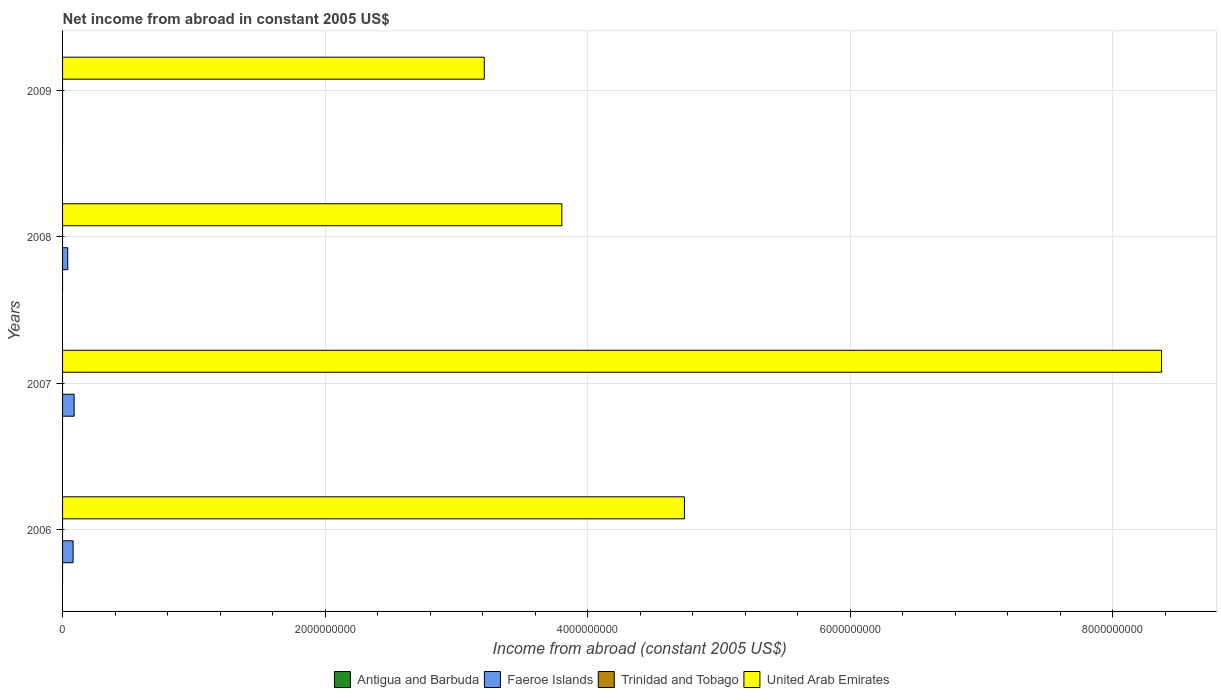How many different coloured bars are there?
Your answer should be very brief. 2. Are the number of bars per tick equal to the number of legend labels?
Provide a succinct answer. No. Are the number of bars on each tick of the Y-axis equal?
Provide a succinct answer. No. How many bars are there on the 1st tick from the bottom?
Your response must be concise. 2. What is the label of the 1st group of bars from the top?
Make the answer very short. 2009. What is the net income from abroad in United Arab Emirates in 2008?
Provide a succinct answer. 3.80e+09. Across all years, what is the maximum net income from abroad in United Arab Emirates?
Your answer should be compact. 8.37e+09. Across all years, what is the minimum net income from abroad in United Arab Emirates?
Keep it short and to the point. 3.21e+09. What is the total net income from abroad in Antigua and Barbuda in the graph?
Your answer should be very brief. 0. What is the difference between the net income from abroad in United Arab Emirates in 2006 and that in 2009?
Make the answer very short. 1.52e+09. What is the difference between the net income from abroad in United Arab Emirates in 2006 and the net income from abroad in Faeroe Islands in 2008?
Your answer should be very brief. 4.70e+09. What is the average net income from abroad in Antigua and Barbuda per year?
Your answer should be compact. 0. In how many years, is the net income from abroad in United Arab Emirates greater than 4800000000 US$?
Ensure brevity in your answer.  1. What is the ratio of the net income from abroad in United Arab Emirates in 2006 to that in 2007?
Give a very brief answer. 0.57. What is the difference between the highest and the second highest net income from abroad in Faeroe Islands?
Make the answer very short. 7.96e+06. What is the difference between the highest and the lowest net income from abroad in Faeroe Islands?
Offer a very short reply. 8.82e+07. Is the sum of the net income from abroad in United Arab Emirates in 2008 and 2009 greater than the maximum net income from abroad in Antigua and Barbuda across all years?
Provide a succinct answer. Yes. Is it the case that in every year, the sum of the net income from abroad in Antigua and Barbuda and net income from abroad in Trinidad and Tobago is greater than the sum of net income from abroad in Faeroe Islands and net income from abroad in United Arab Emirates?
Offer a terse response. No. Is it the case that in every year, the sum of the net income from abroad in United Arab Emirates and net income from abroad in Trinidad and Tobago is greater than the net income from abroad in Antigua and Barbuda?
Keep it short and to the point. Yes. How many years are there in the graph?
Ensure brevity in your answer.  4. What is the difference between two consecutive major ticks on the X-axis?
Offer a terse response. 2.00e+09. Does the graph contain any zero values?
Keep it short and to the point. Yes. Does the graph contain grids?
Your response must be concise. Yes. How are the legend labels stacked?
Ensure brevity in your answer.  Horizontal. What is the title of the graph?
Give a very brief answer. Net income from abroad in constant 2005 US$. What is the label or title of the X-axis?
Your answer should be compact. Income from abroad (constant 2005 US$). What is the Income from abroad (constant 2005 US$) of Faeroe Islands in 2006?
Your answer should be very brief. 8.02e+07. What is the Income from abroad (constant 2005 US$) in United Arab Emirates in 2006?
Ensure brevity in your answer.  4.74e+09. What is the Income from abroad (constant 2005 US$) of Faeroe Islands in 2007?
Your answer should be compact. 8.82e+07. What is the Income from abroad (constant 2005 US$) of Trinidad and Tobago in 2007?
Your response must be concise. 0. What is the Income from abroad (constant 2005 US$) in United Arab Emirates in 2007?
Give a very brief answer. 8.37e+09. What is the Income from abroad (constant 2005 US$) of Antigua and Barbuda in 2008?
Provide a succinct answer. 0. What is the Income from abroad (constant 2005 US$) in Faeroe Islands in 2008?
Give a very brief answer. 3.96e+07. What is the Income from abroad (constant 2005 US$) of United Arab Emirates in 2008?
Your answer should be very brief. 3.80e+09. What is the Income from abroad (constant 2005 US$) in Antigua and Barbuda in 2009?
Provide a short and direct response. 0. What is the Income from abroad (constant 2005 US$) in Trinidad and Tobago in 2009?
Provide a short and direct response. 0. What is the Income from abroad (constant 2005 US$) of United Arab Emirates in 2009?
Make the answer very short. 3.21e+09. Across all years, what is the maximum Income from abroad (constant 2005 US$) in Faeroe Islands?
Ensure brevity in your answer.  8.82e+07. Across all years, what is the maximum Income from abroad (constant 2005 US$) of United Arab Emirates?
Offer a very short reply. 8.37e+09. Across all years, what is the minimum Income from abroad (constant 2005 US$) in United Arab Emirates?
Provide a short and direct response. 3.21e+09. What is the total Income from abroad (constant 2005 US$) of Faeroe Islands in the graph?
Offer a terse response. 2.08e+08. What is the total Income from abroad (constant 2005 US$) in United Arab Emirates in the graph?
Make the answer very short. 2.01e+1. What is the difference between the Income from abroad (constant 2005 US$) in Faeroe Islands in 2006 and that in 2007?
Ensure brevity in your answer.  -7.96e+06. What is the difference between the Income from abroad (constant 2005 US$) of United Arab Emirates in 2006 and that in 2007?
Provide a succinct answer. -3.64e+09. What is the difference between the Income from abroad (constant 2005 US$) in Faeroe Islands in 2006 and that in 2008?
Offer a terse response. 4.06e+07. What is the difference between the Income from abroad (constant 2005 US$) of United Arab Emirates in 2006 and that in 2008?
Offer a terse response. 9.34e+08. What is the difference between the Income from abroad (constant 2005 US$) in United Arab Emirates in 2006 and that in 2009?
Your answer should be compact. 1.52e+09. What is the difference between the Income from abroad (constant 2005 US$) of Faeroe Islands in 2007 and that in 2008?
Keep it short and to the point. 4.86e+07. What is the difference between the Income from abroad (constant 2005 US$) of United Arab Emirates in 2007 and that in 2008?
Your answer should be very brief. 4.57e+09. What is the difference between the Income from abroad (constant 2005 US$) in United Arab Emirates in 2007 and that in 2009?
Ensure brevity in your answer.  5.16e+09. What is the difference between the Income from abroad (constant 2005 US$) in United Arab Emirates in 2008 and that in 2009?
Give a very brief answer. 5.91e+08. What is the difference between the Income from abroad (constant 2005 US$) in Faeroe Islands in 2006 and the Income from abroad (constant 2005 US$) in United Arab Emirates in 2007?
Provide a short and direct response. -8.29e+09. What is the difference between the Income from abroad (constant 2005 US$) in Faeroe Islands in 2006 and the Income from abroad (constant 2005 US$) in United Arab Emirates in 2008?
Ensure brevity in your answer.  -3.72e+09. What is the difference between the Income from abroad (constant 2005 US$) of Faeroe Islands in 2006 and the Income from abroad (constant 2005 US$) of United Arab Emirates in 2009?
Give a very brief answer. -3.13e+09. What is the difference between the Income from abroad (constant 2005 US$) in Faeroe Islands in 2007 and the Income from abroad (constant 2005 US$) in United Arab Emirates in 2008?
Your response must be concise. -3.72e+09. What is the difference between the Income from abroad (constant 2005 US$) of Faeroe Islands in 2007 and the Income from abroad (constant 2005 US$) of United Arab Emirates in 2009?
Provide a succinct answer. -3.12e+09. What is the difference between the Income from abroad (constant 2005 US$) in Faeroe Islands in 2008 and the Income from abroad (constant 2005 US$) in United Arab Emirates in 2009?
Give a very brief answer. -3.17e+09. What is the average Income from abroad (constant 2005 US$) in Antigua and Barbuda per year?
Offer a very short reply. 0. What is the average Income from abroad (constant 2005 US$) in Faeroe Islands per year?
Give a very brief answer. 5.20e+07. What is the average Income from abroad (constant 2005 US$) in Trinidad and Tobago per year?
Make the answer very short. 0. What is the average Income from abroad (constant 2005 US$) in United Arab Emirates per year?
Provide a succinct answer. 5.03e+09. In the year 2006, what is the difference between the Income from abroad (constant 2005 US$) in Faeroe Islands and Income from abroad (constant 2005 US$) in United Arab Emirates?
Ensure brevity in your answer.  -4.66e+09. In the year 2007, what is the difference between the Income from abroad (constant 2005 US$) in Faeroe Islands and Income from abroad (constant 2005 US$) in United Arab Emirates?
Provide a short and direct response. -8.28e+09. In the year 2008, what is the difference between the Income from abroad (constant 2005 US$) in Faeroe Islands and Income from abroad (constant 2005 US$) in United Arab Emirates?
Provide a short and direct response. -3.76e+09. What is the ratio of the Income from abroad (constant 2005 US$) in Faeroe Islands in 2006 to that in 2007?
Provide a succinct answer. 0.91. What is the ratio of the Income from abroad (constant 2005 US$) in United Arab Emirates in 2006 to that in 2007?
Ensure brevity in your answer.  0.57. What is the ratio of the Income from abroad (constant 2005 US$) in Faeroe Islands in 2006 to that in 2008?
Your response must be concise. 2.02. What is the ratio of the Income from abroad (constant 2005 US$) of United Arab Emirates in 2006 to that in 2008?
Your answer should be compact. 1.25. What is the ratio of the Income from abroad (constant 2005 US$) of United Arab Emirates in 2006 to that in 2009?
Your response must be concise. 1.47. What is the ratio of the Income from abroad (constant 2005 US$) in Faeroe Islands in 2007 to that in 2008?
Make the answer very short. 2.23. What is the ratio of the Income from abroad (constant 2005 US$) in United Arab Emirates in 2007 to that in 2008?
Make the answer very short. 2.2. What is the ratio of the Income from abroad (constant 2005 US$) in United Arab Emirates in 2007 to that in 2009?
Offer a terse response. 2.61. What is the ratio of the Income from abroad (constant 2005 US$) of United Arab Emirates in 2008 to that in 2009?
Make the answer very short. 1.18. What is the difference between the highest and the second highest Income from abroad (constant 2005 US$) of Faeroe Islands?
Provide a short and direct response. 7.96e+06. What is the difference between the highest and the second highest Income from abroad (constant 2005 US$) in United Arab Emirates?
Give a very brief answer. 3.64e+09. What is the difference between the highest and the lowest Income from abroad (constant 2005 US$) of Faeroe Islands?
Offer a very short reply. 8.82e+07. What is the difference between the highest and the lowest Income from abroad (constant 2005 US$) of United Arab Emirates?
Offer a terse response. 5.16e+09. 